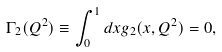Convert formula to latex. <formula><loc_0><loc_0><loc_500><loc_500>\Gamma _ { 2 } ( Q ^ { 2 } ) \equiv \int _ { 0 } ^ { 1 } d x g _ { 2 } ( x , Q ^ { 2 } ) = 0 ,</formula> 